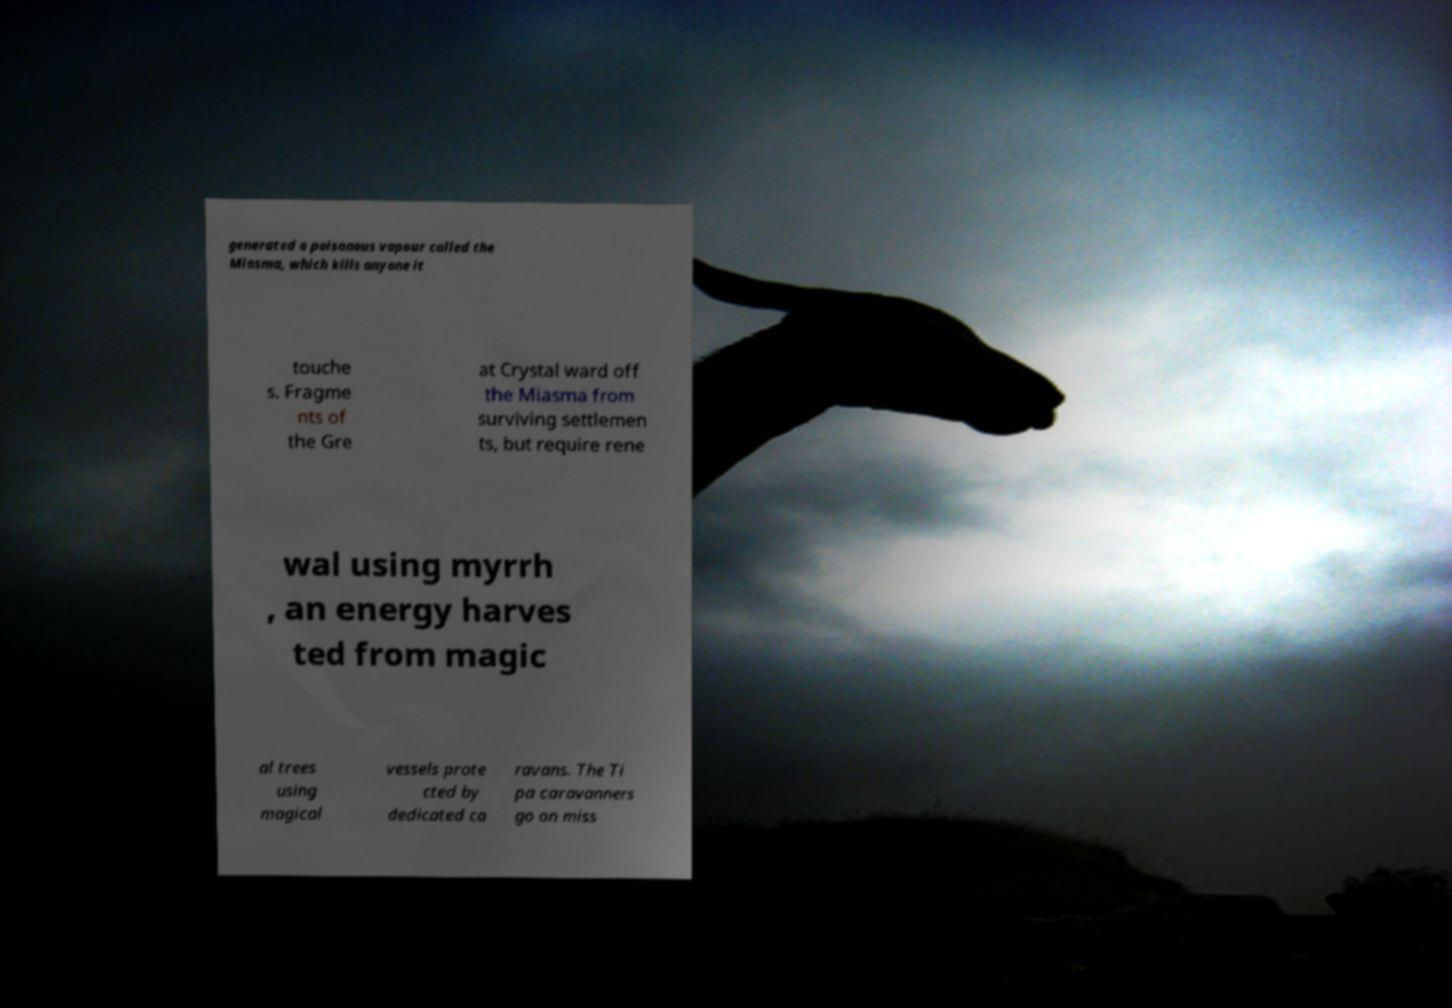Can you read and provide the text displayed in the image?This photo seems to have some interesting text. Can you extract and type it out for me? generated a poisonous vapour called the Miasma, which kills anyone it touche s. Fragme nts of the Gre at Crystal ward off the Miasma from surviving settlemen ts, but require rene wal using myrrh , an energy harves ted from magic al trees using magical vessels prote cted by dedicated ca ravans. The Ti pa caravanners go on miss 